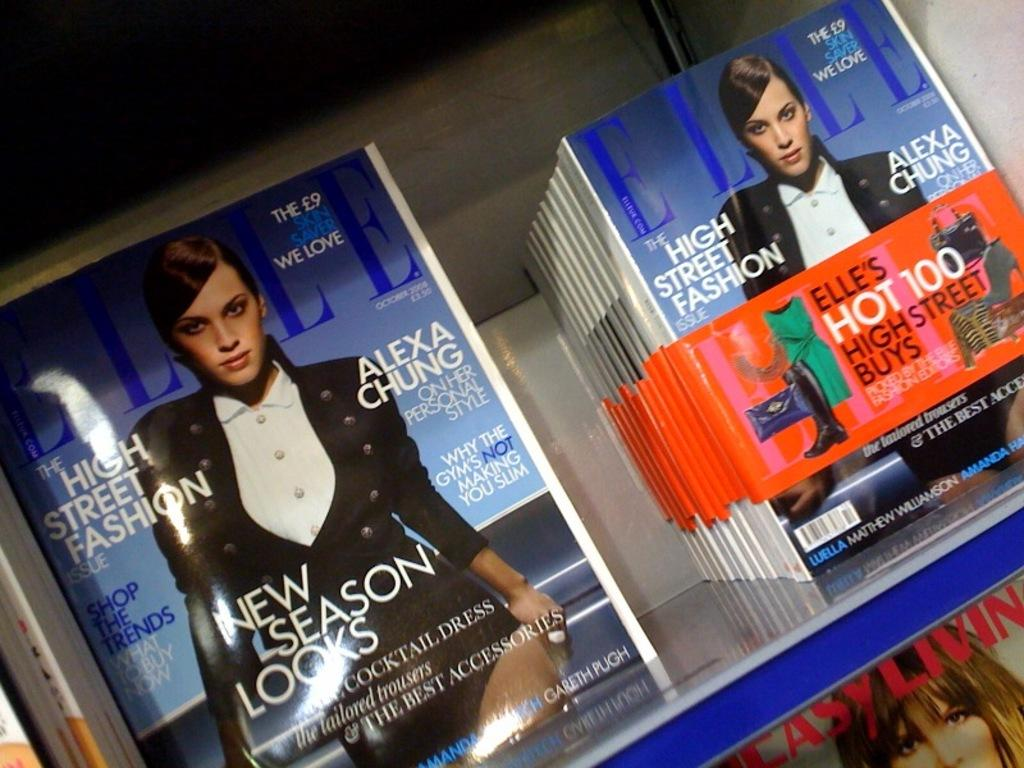<image>
Write a terse but informative summary of the picture. A stack of Elle Magazines feature a New Season Looks segment. 